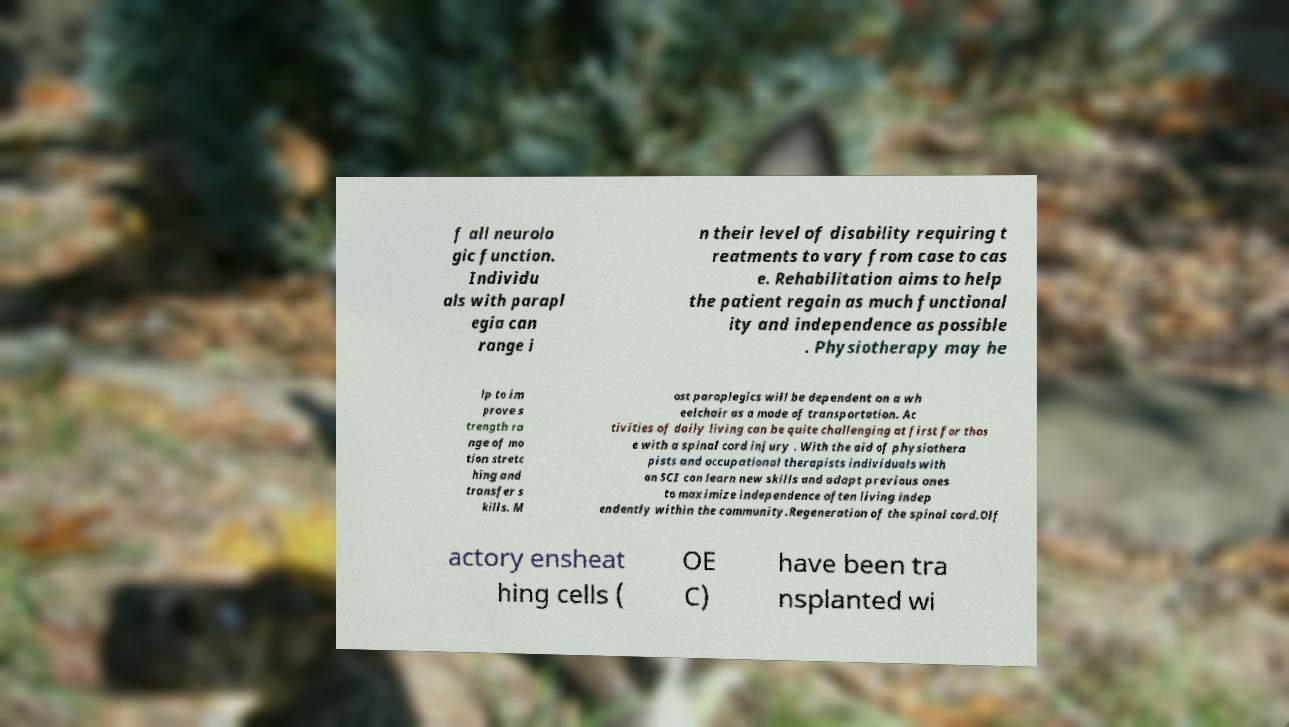What messages or text are displayed in this image? I need them in a readable, typed format. f all neurolo gic function. Individu als with parapl egia can range i n their level of disability requiring t reatments to vary from case to cas e. Rehabilitation aims to help the patient regain as much functional ity and independence as possible . Physiotherapy may he lp to im prove s trength ra nge of mo tion stretc hing and transfer s kills. M ost paraplegics will be dependent on a wh eelchair as a mode of transportation. Ac tivities of daily living can be quite challenging at first for thos e with a spinal cord injury . With the aid of physiothera pists and occupational therapists individuals with an SCI can learn new skills and adapt previous ones to maximize independence often living indep endently within the community.Regeneration of the spinal cord.Olf actory ensheat hing cells ( OE C) have been tra nsplanted wi 